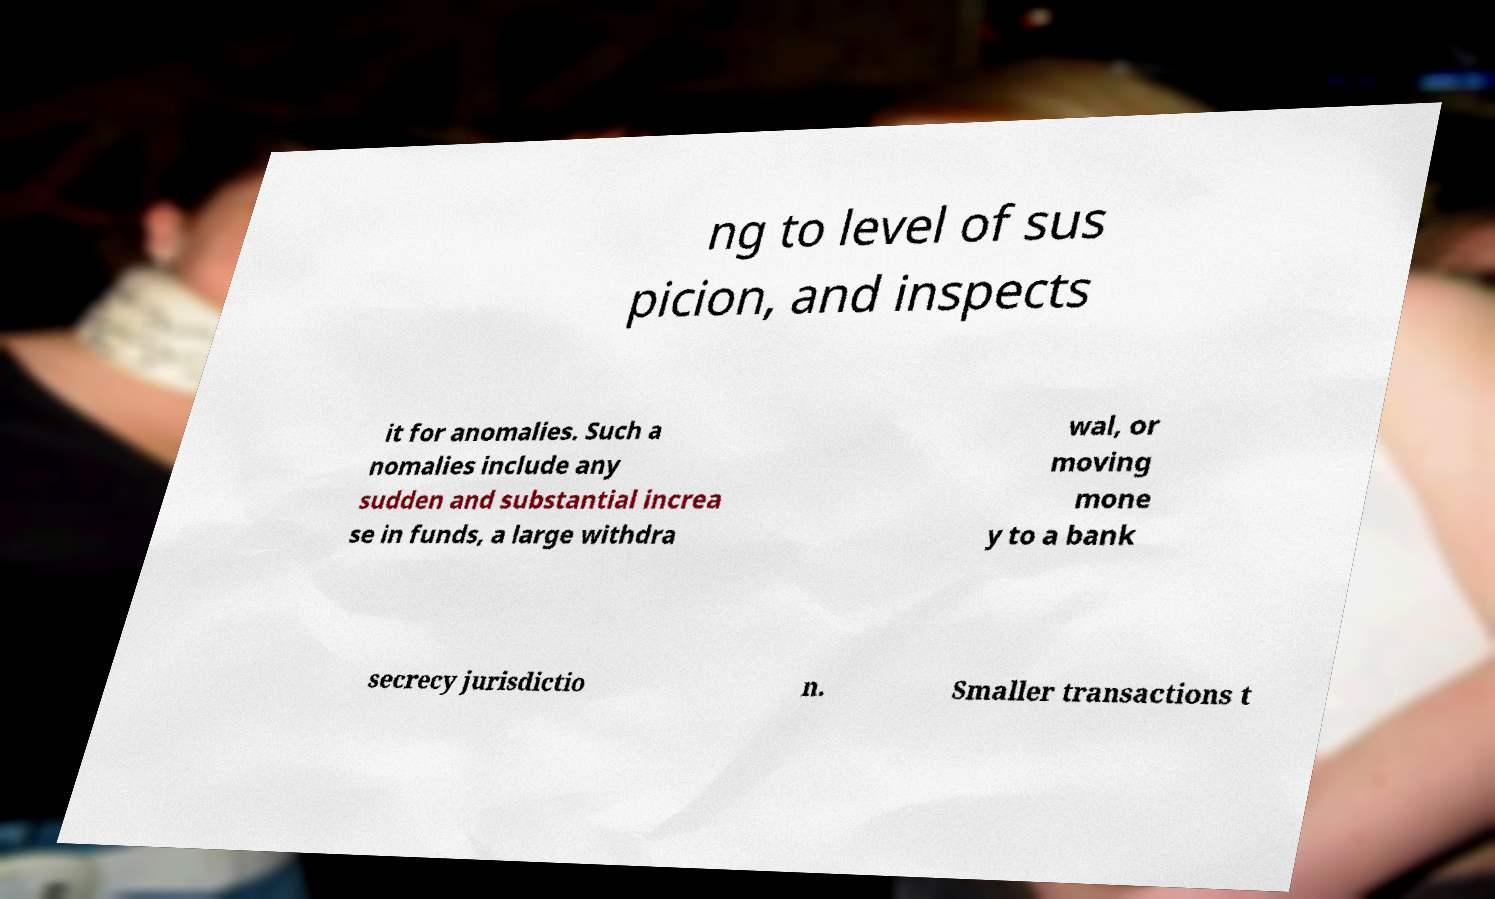Could you extract and type out the text from this image? ng to level of sus picion, and inspects it for anomalies. Such a nomalies include any sudden and substantial increa se in funds, a large withdra wal, or moving mone y to a bank secrecy jurisdictio n. Smaller transactions t 